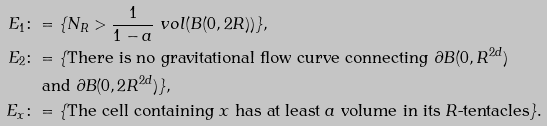<formula> <loc_0><loc_0><loc_500><loc_500>E _ { 1 } & \colon = \{ N _ { R } > \frac { 1 } { 1 - a } \ v o l ( B ( 0 , 2 R ) ) \} , \\ E _ { 2 } & \colon = \{ \text {There is no gravitational flow curve connecting $\partial B(0,R^{2d})$} \\ & \quad \text {and } \partial B ( 0 , 2 R ^ { 2 d } ) \} , \\ E _ { x } & \colon = \{ \text {The cell containing $x$ has at least $a$ volume in its $R$-tentacles} \} .</formula> 